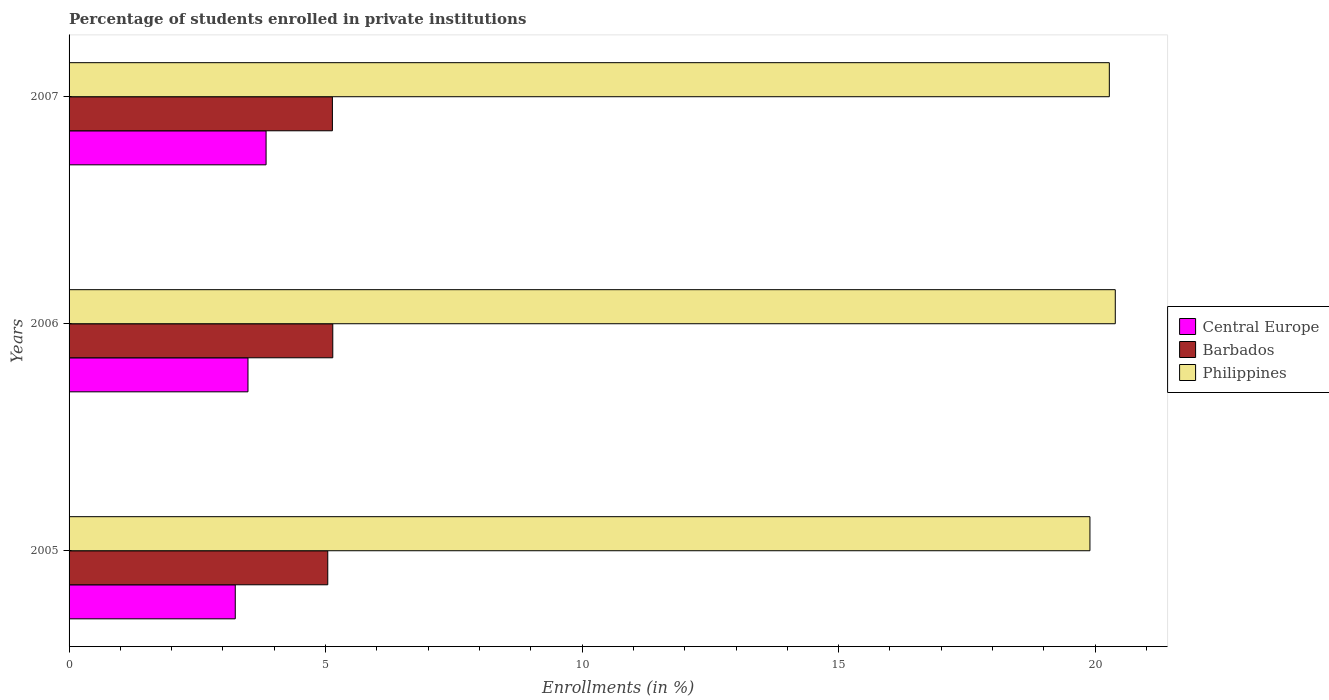How many different coloured bars are there?
Offer a terse response. 3. Are the number of bars per tick equal to the number of legend labels?
Your answer should be very brief. Yes. Are the number of bars on each tick of the Y-axis equal?
Your answer should be very brief. Yes. How many bars are there on the 2nd tick from the top?
Your answer should be compact. 3. What is the label of the 3rd group of bars from the top?
Your answer should be very brief. 2005. In how many cases, is the number of bars for a given year not equal to the number of legend labels?
Ensure brevity in your answer.  0. What is the percentage of trained teachers in Philippines in 2005?
Your answer should be compact. 19.9. Across all years, what is the maximum percentage of trained teachers in Barbados?
Keep it short and to the point. 5.14. Across all years, what is the minimum percentage of trained teachers in Central Europe?
Give a very brief answer. 3.24. In which year was the percentage of trained teachers in Central Europe maximum?
Give a very brief answer. 2007. In which year was the percentage of trained teachers in Barbados minimum?
Your response must be concise. 2005. What is the total percentage of trained teachers in Barbados in the graph?
Provide a succinct answer. 15.32. What is the difference between the percentage of trained teachers in Central Europe in 2005 and that in 2006?
Give a very brief answer. -0.25. What is the difference between the percentage of trained teachers in Central Europe in 2006 and the percentage of trained teachers in Barbados in 2005?
Provide a succinct answer. -1.56. What is the average percentage of trained teachers in Central Europe per year?
Make the answer very short. 3.52. In the year 2005, what is the difference between the percentage of trained teachers in Central Europe and percentage of trained teachers in Philippines?
Your answer should be compact. -16.66. What is the ratio of the percentage of trained teachers in Central Europe in 2005 to that in 2007?
Keep it short and to the point. 0.84. Is the difference between the percentage of trained teachers in Central Europe in 2006 and 2007 greater than the difference between the percentage of trained teachers in Philippines in 2006 and 2007?
Your response must be concise. No. What is the difference between the highest and the second highest percentage of trained teachers in Central Europe?
Offer a very short reply. 0.35. What is the difference between the highest and the lowest percentage of trained teachers in Barbados?
Provide a short and direct response. 0.1. Is the sum of the percentage of trained teachers in Barbados in 2005 and 2006 greater than the maximum percentage of trained teachers in Central Europe across all years?
Keep it short and to the point. Yes. Is it the case that in every year, the sum of the percentage of trained teachers in Philippines and percentage of trained teachers in Barbados is greater than the percentage of trained teachers in Central Europe?
Your answer should be compact. Yes. How many years are there in the graph?
Provide a succinct answer. 3. What is the difference between two consecutive major ticks on the X-axis?
Keep it short and to the point. 5. Does the graph contain any zero values?
Give a very brief answer. No. Where does the legend appear in the graph?
Provide a succinct answer. Center right. What is the title of the graph?
Your answer should be very brief. Percentage of students enrolled in private institutions. What is the label or title of the X-axis?
Provide a succinct answer. Enrollments (in %). What is the label or title of the Y-axis?
Offer a terse response. Years. What is the Enrollments (in %) of Central Europe in 2005?
Your answer should be very brief. 3.24. What is the Enrollments (in %) in Barbados in 2005?
Give a very brief answer. 5.04. What is the Enrollments (in %) in Philippines in 2005?
Your response must be concise. 19.9. What is the Enrollments (in %) in Central Europe in 2006?
Ensure brevity in your answer.  3.49. What is the Enrollments (in %) of Barbados in 2006?
Your response must be concise. 5.14. What is the Enrollments (in %) in Philippines in 2006?
Ensure brevity in your answer.  20.39. What is the Enrollments (in %) of Central Europe in 2007?
Provide a short and direct response. 3.84. What is the Enrollments (in %) of Barbados in 2007?
Your answer should be compact. 5.13. What is the Enrollments (in %) of Philippines in 2007?
Your answer should be compact. 20.28. Across all years, what is the maximum Enrollments (in %) in Central Europe?
Give a very brief answer. 3.84. Across all years, what is the maximum Enrollments (in %) in Barbados?
Make the answer very short. 5.14. Across all years, what is the maximum Enrollments (in %) in Philippines?
Your response must be concise. 20.39. Across all years, what is the minimum Enrollments (in %) in Central Europe?
Provide a short and direct response. 3.24. Across all years, what is the minimum Enrollments (in %) of Barbados?
Offer a very short reply. 5.04. Across all years, what is the minimum Enrollments (in %) in Philippines?
Your answer should be compact. 19.9. What is the total Enrollments (in %) in Central Europe in the graph?
Ensure brevity in your answer.  10.57. What is the total Enrollments (in %) in Barbados in the graph?
Your response must be concise. 15.32. What is the total Enrollments (in %) in Philippines in the graph?
Your answer should be compact. 60.57. What is the difference between the Enrollments (in %) of Central Europe in 2005 and that in 2006?
Your answer should be very brief. -0.25. What is the difference between the Enrollments (in %) of Barbados in 2005 and that in 2006?
Your answer should be very brief. -0.1. What is the difference between the Enrollments (in %) of Philippines in 2005 and that in 2006?
Offer a very short reply. -0.49. What is the difference between the Enrollments (in %) of Central Europe in 2005 and that in 2007?
Keep it short and to the point. -0.6. What is the difference between the Enrollments (in %) of Barbados in 2005 and that in 2007?
Make the answer very short. -0.09. What is the difference between the Enrollments (in %) in Philippines in 2005 and that in 2007?
Give a very brief answer. -0.38. What is the difference between the Enrollments (in %) of Central Europe in 2006 and that in 2007?
Make the answer very short. -0.35. What is the difference between the Enrollments (in %) of Barbados in 2006 and that in 2007?
Offer a very short reply. 0.01. What is the difference between the Enrollments (in %) in Philippines in 2006 and that in 2007?
Give a very brief answer. 0.12. What is the difference between the Enrollments (in %) in Central Europe in 2005 and the Enrollments (in %) in Barbados in 2006?
Give a very brief answer. -1.9. What is the difference between the Enrollments (in %) in Central Europe in 2005 and the Enrollments (in %) in Philippines in 2006?
Give a very brief answer. -17.15. What is the difference between the Enrollments (in %) in Barbados in 2005 and the Enrollments (in %) in Philippines in 2006?
Offer a terse response. -15.35. What is the difference between the Enrollments (in %) in Central Europe in 2005 and the Enrollments (in %) in Barbados in 2007?
Your answer should be compact. -1.89. What is the difference between the Enrollments (in %) in Central Europe in 2005 and the Enrollments (in %) in Philippines in 2007?
Ensure brevity in your answer.  -17.04. What is the difference between the Enrollments (in %) of Barbados in 2005 and the Enrollments (in %) of Philippines in 2007?
Provide a short and direct response. -15.23. What is the difference between the Enrollments (in %) of Central Europe in 2006 and the Enrollments (in %) of Barbados in 2007?
Your response must be concise. -1.65. What is the difference between the Enrollments (in %) of Central Europe in 2006 and the Enrollments (in %) of Philippines in 2007?
Your answer should be compact. -16.79. What is the difference between the Enrollments (in %) in Barbados in 2006 and the Enrollments (in %) in Philippines in 2007?
Ensure brevity in your answer.  -15.14. What is the average Enrollments (in %) of Central Europe per year?
Offer a very short reply. 3.52. What is the average Enrollments (in %) of Barbados per year?
Keep it short and to the point. 5.11. What is the average Enrollments (in %) in Philippines per year?
Keep it short and to the point. 20.19. In the year 2005, what is the difference between the Enrollments (in %) of Central Europe and Enrollments (in %) of Barbados?
Make the answer very short. -1.8. In the year 2005, what is the difference between the Enrollments (in %) of Central Europe and Enrollments (in %) of Philippines?
Keep it short and to the point. -16.66. In the year 2005, what is the difference between the Enrollments (in %) of Barbados and Enrollments (in %) of Philippines?
Offer a very short reply. -14.86. In the year 2006, what is the difference between the Enrollments (in %) in Central Europe and Enrollments (in %) in Barbados?
Offer a terse response. -1.65. In the year 2006, what is the difference between the Enrollments (in %) in Central Europe and Enrollments (in %) in Philippines?
Provide a succinct answer. -16.9. In the year 2006, what is the difference between the Enrollments (in %) in Barbados and Enrollments (in %) in Philippines?
Offer a very short reply. -15.25. In the year 2007, what is the difference between the Enrollments (in %) of Central Europe and Enrollments (in %) of Barbados?
Ensure brevity in your answer.  -1.29. In the year 2007, what is the difference between the Enrollments (in %) in Central Europe and Enrollments (in %) in Philippines?
Ensure brevity in your answer.  -16.44. In the year 2007, what is the difference between the Enrollments (in %) of Barbados and Enrollments (in %) of Philippines?
Provide a short and direct response. -15.14. What is the ratio of the Enrollments (in %) in Central Europe in 2005 to that in 2006?
Keep it short and to the point. 0.93. What is the ratio of the Enrollments (in %) of Barbados in 2005 to that in 2006?
Your answer should be very brief. 0.98. What is the ratio of the Enrollments (in %) in Philippines in 2005 to that in 2006?
Provide a succinct answer. 0.98. What is the ratio of the Enrollments (in %) in Central Europe in 2005 to that in 2007?
Offer a terse response. 0.84. What is the ratio of the Enrollments (in %) of Barbados in 2005 to that in 2007?
Ensure brevity in your answer.  0.98. What is the ratio of the Enrollments (in %) of Philippines in 2005 to that in 2007?
Your answer should be compact. 0.98. What is the ratio of the Enrollments (in %) in Central Europe in 2006 to that in 2007?
Give a very brief answer. 0.91. What is the ratio of the Enrollments (in %) of Barbados in 2006 to that in 2007?
Provide a short and direct response. 1. What is the difference between the highest and the second highest Enrollments (in %) in Central Europe?
Your answer should be compact. 0.35. What is the difference between the highest and the second highest Enrollments (in %) in Barbados?
Your answer should be very brief. 0.01. What is the difference between the highest and the second highest Enrollments (in %) in Philippines?
Provide a succinct answer. 0.12. What is the difference between the highest and the lowest Enrollments (in %) of Central Europe?
Offer a terse response. 0.6. What is the difference between the highest and the lowest Enrollments (in %) in Barbados?
Ensure brevity in your answer.  0.1. What is the difference between the highest and the lowest Enrollments (in %) of Philippines?
Offer a terse response. 0.49. 